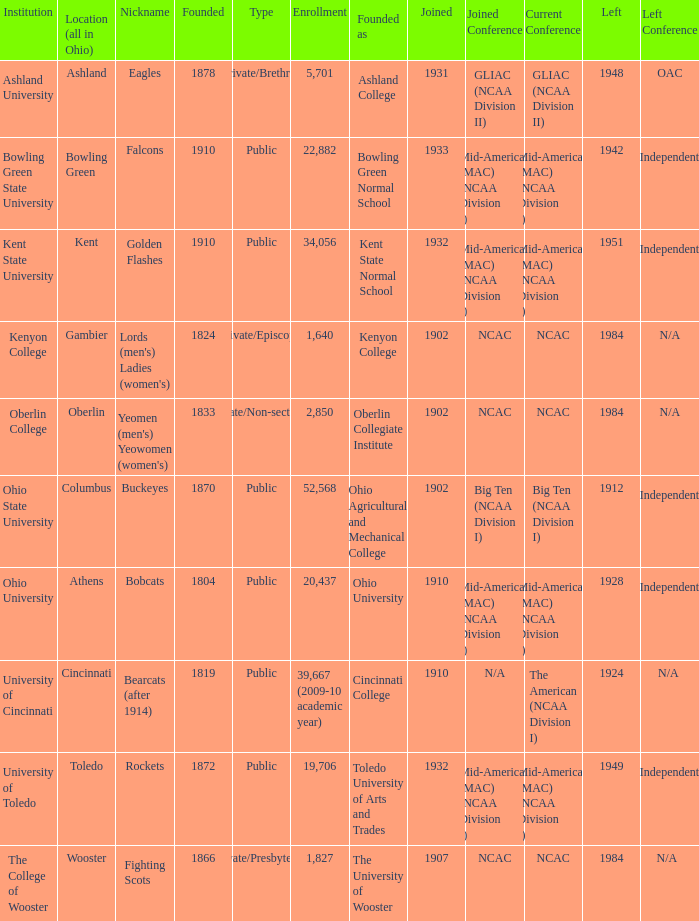What is the type of institution in Kent State University? Public. 